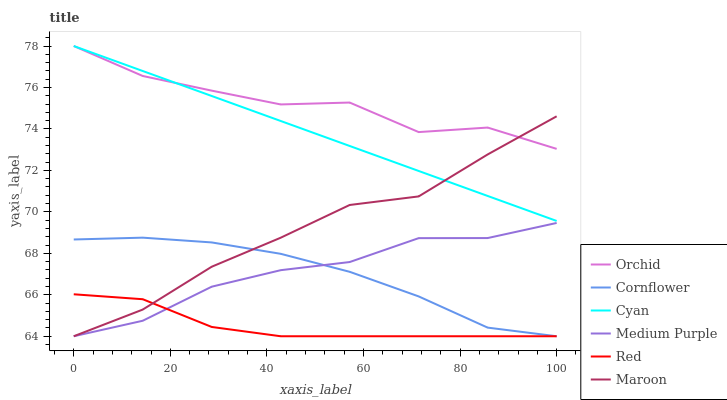Does Red have the minimum area under the curve?
Answer yes or no. Yes. Does Orchid have the maximum area under the curve?
Answer yes or no. Yes. Does Maroon have the minimum area under the curve?
Answer yes or no. No. Does Maroon have the maximum area under the curve?
Answer yes or no. No. Is Cyan the smoothest?
Answer yes or no. Yes. Is Orchid the roughest?
Answer yes or no. Yes. Is Maroon the smoothest?
Answer yes or no. No. Is Maroon the roughest?
Answer yes or no. No. Does Cornflower have the lowest value?
Answer yes or no. Yes. Does Cyan have the lowest value?
Answer yes or no. No. Does Orchid have the highest value?
Answer yes or no. Yes. Does Maroon have the highest value?
Answer yes or no. No. Is Medium Purple less than Cyan?
Answer yes or no. Yes. Is Orchid greater than Cornflower?
Answer yes or no. Yes. Does Red intersect Maroon?
Answer yes or no. Yes. Is Red less than Maroon?
Answer yes or no. No. Is Red greater than Maroon?
Answer yes or no. No. Does Medium Purple intersect Cyan?
Answer yes or no. No. 